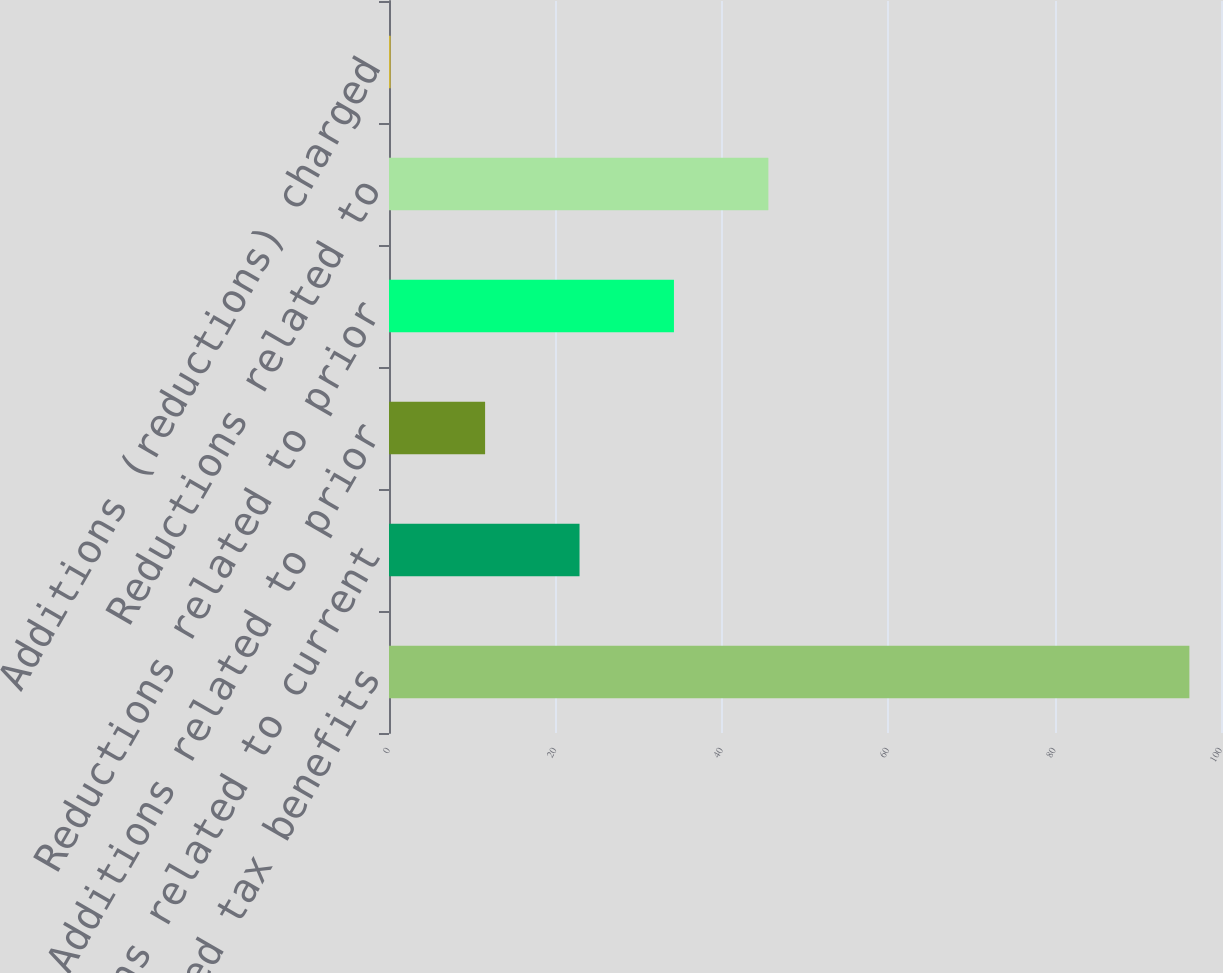<chart> <loc_0><loc_0><loc_500><loc_500><bar_chart><fcel>Unrecognized tax benefits<fcel>Additions related to current<fcel>Additions related to prior<fcel>Reductions related to prior<fcel>Reductions related to<fcel>Additions (reductions) charged<nl><fcel>96.2<fcel>22.9<fcel>11.55<fcel>34.25<fcel>45.6<fcel>0.2<nl></chart> 